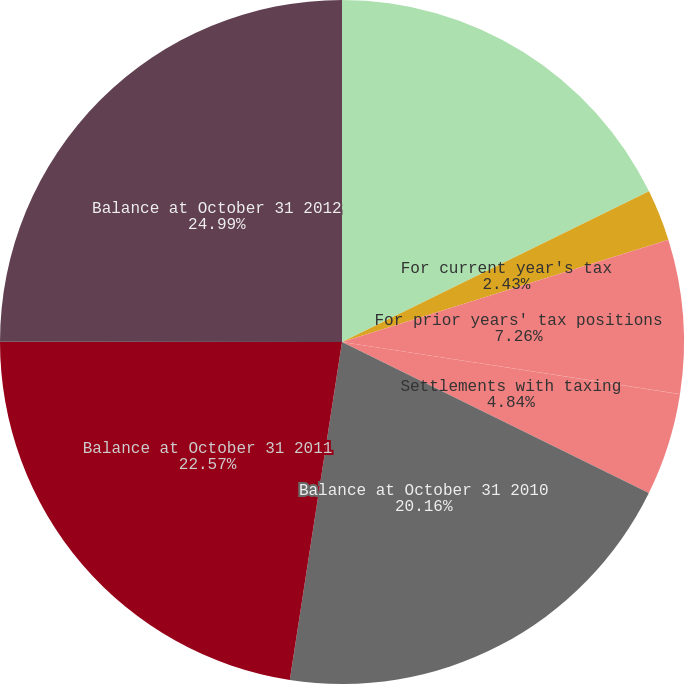Convert chart. <chart><loc_0><loc_0><loc_500><loc_500><pie_chart><fcel>Balance at October 31 2009<fcel>For current year's tax<fcel>For prior years' tax positions<fcel>Statute of limitations<fcel>Settlements with taxing<fcel>Balance at October 31 2010<fcel>Balance at October 31 2011<fcel>Balance at October 31 2012<nl><fcel>17.74%<fcel>2.43%<fcel>7.26%<fcel>0.01%<fcel>4.84%<fcel>20.16%<fcel>22.57%<fcel>24.99%<nl></chart> 